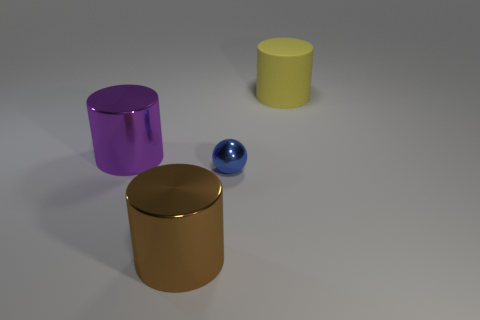Can you describe the texture and color of the biggest object in the image? The largest object in the image is a gold cylinder with a smooth metallic texture and a reflective surface that shows its surroundings subtlety. 